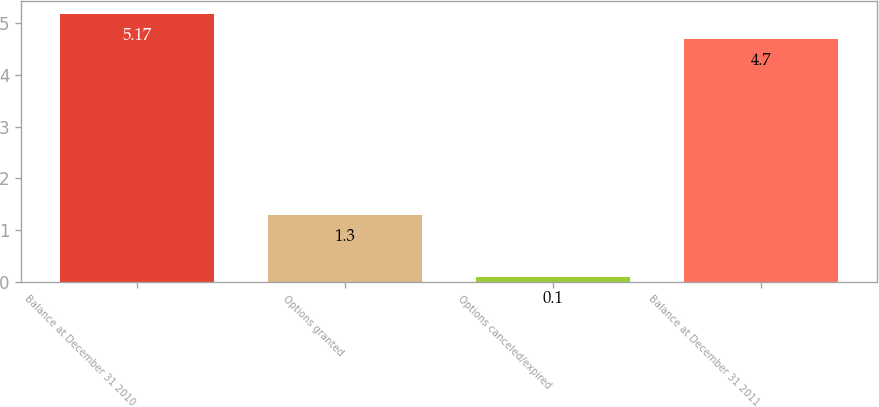<chart> <loc_0><loc_0><loc_500><loc_500><bar_chart><fcel>Balance at December 31 2010<fcel>Options granted<fcel>Options canceled/expired<fcel>Balance at December 31 2011<nl><fcel>5.17<fcel>1.3<fcel>0.1<fcel>4.7<nl></chart> 